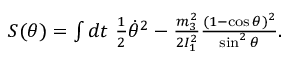Convert formula to latex. <formula><loc_0><loc_0><loc_500><loc_500>\begin{array} { r } { S ( \theta ) = \int d t \frac { 1 } { 2 } \dot { \theta } ^ { 2 } - \frac { m _ { 3 } ^ { 2 } } { 2 I _ { 1 } ^ { 2 } } \frac { ( 1 - \cos \theta ) ^ { 2 } } { \sin ^ { 2 } \theta } . } \end{array}</formula> 